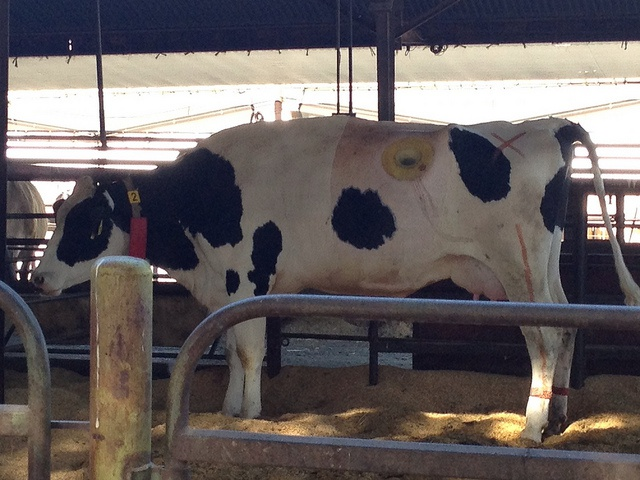Describe the objects in this image and their specific colors. I can see a cow in black, gray, and maroon tones in this image. 